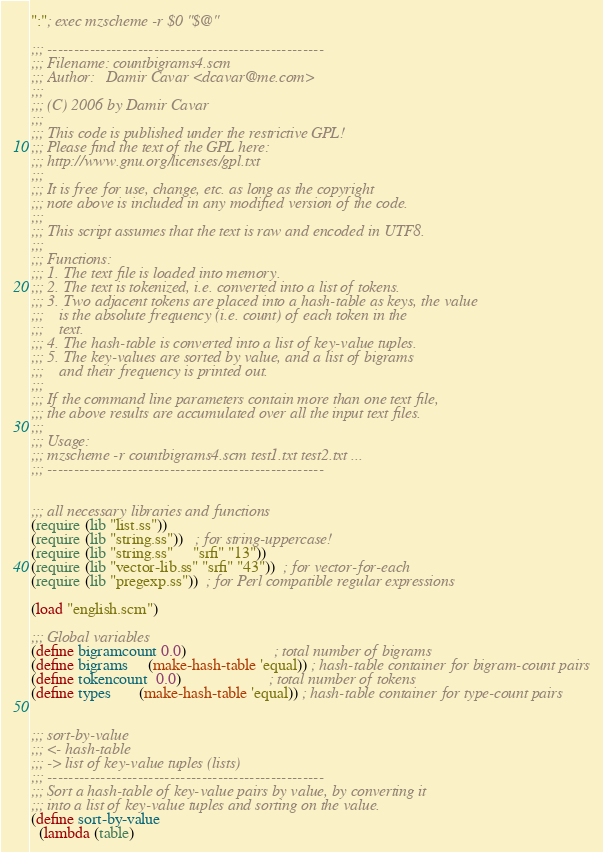Convert code to text. <code><loc_0><loc_0><loc_500><loc_500><_Scheme_>":"; exec mzscheme -r $0 "$@"

;;; ----------------------------------------------------
;;; Filename: countbigrams4.scm
;;; Author:   Damir Cavar <dcavar@me.com>
;;;
;;; (C) 2006 by Damir Cavar
;;;
;;; This code is published under the restrictive GPL!
;;; Please find the text of the GPL here:
;;; http://www.gnu.org/licenses/gpl.txt
;;; 
;;; It is free for use, change, etc. as long as the copyright
;;; note above is included in any modified version of the code.
;;; 
;;; This script assumes that the text is raw and encoded in UTF8.
;;;
;;; Functions:
;;; 1. The text file is loaded into memory.
;;; 2. The text is tokenized, i.e. converted into a list of tokens.
;;; 3. Two adjacent tokens are placed into a hash-table as keys, the value
;;;    is the absolute frequency (i.e. count) of each token in the
;;;    text.
;;; 4. The hash-table is converted into a list of key-value tuples.
;;; 5. The key-values are sorted by value, and a list of bigrams
;;;    and their frequency is printed out.
;;;
;;; If the command line parameters contain more than one text file,
;;; the above results are accumulated over all the input text files.
;;;
;;; Usage:
;;; mzscheme -r countbigrams4.scm test1.txt test2.txt ...
;;; ----------------------------------------------------


;;; all necessary libraries and functions
(require (lib "list.ss"))
(require (lib "string.ss"))   ; for string-uppercase!
(require (lib "string.ss"     "srfi" "13"))
(require (lib "vector-lib.ss" "srfi" "43"))  ; for vector-for-each
(require (lib "pregexp.ss"))  ; for Perl compatible regular expressions

(load "english.scm")

;;; Global variables
(define bigramcount 0.0)                      ; total number of bigrams
(define bigrams     (make-hash-table 'equal)) ; hash-table container for bigram-count pairs
(define tokencount  0.0)                      ; total number of tokens
(define types       (make-hash-table 'equal)) ; hash-table container for type-count pairs


;;; sort-by-value
;;; <- hash-table
;;; -> list of key-value tuples (lists)
;;; ----------------------------------------------------
;;; Sort a hash-table of key-value pairs by value, by converting it
;;; into a list of key-value tuples and sorting on the value.
(define sort-by-value
  (lambda (table)</code> 